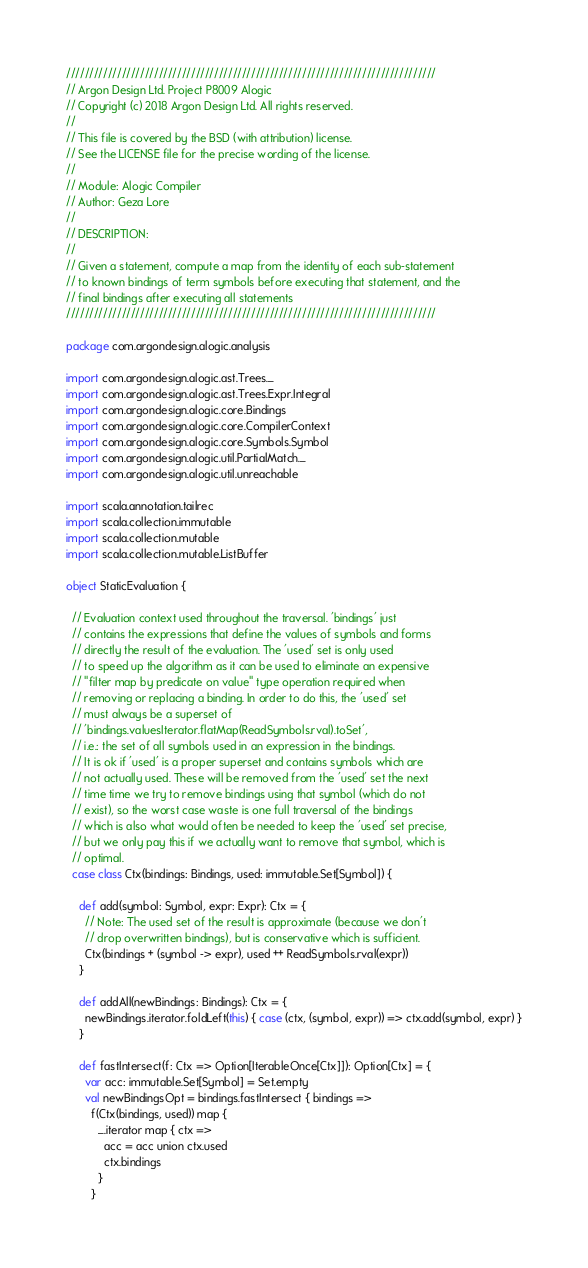<code> <loc_0><loc_0><loc_500><loc_500><_Scala_>////////////////////////////////////////////////////////////////////////////////
// Argon Design Ltd. Project P8009 Alogic
// Copyright (c) 2018 Argon Design Ltd. All rights reserved.
//
// This file is covered by the BSD (with attribution) license.
// See the LICENSE file for the precise wording of the license.
//
// Module: Alogic Compiler
// Author: Geza Lore
//
// DESCRIPTION:
//
// Given a statement, compute a map from the identity of each sub-statement
// to known bindings of term symbols before executing that statement, and the
// final bindings after executing all statements
////////////////////////////////////////////////////////////////////////////////

package com.argondesign.alogic.analysis

import com.argondesign.alogic.ast.Trees._
import com.argondesign.alogic.ast.Trees.Expr.Integral
import com.argondesign.alogic.core.Bindings
import com.argondesign.alogic.core.CompilerContext
import com.argondesign.alogic.core.Symbols.Symbol
import com.argondesign.alogic.util.PartialMatch._
import com.argondesign.alogic.util.unreachable

import scala.annotation.tailrec
import scala.collection.immutable
import scala.collection.mutable
import scala.collection.mutable.ListBuffer

object StaticEvaluation {

  // Evaluation context used throughout the traversal. 'bindings' just
  // contains the expressions that define the values of symbols and forms
  // directly the result of the evaluation. The 'used' set is only used
  // to speed up the algorithm as it can be used to eliminate an expensive
  // "filter map by predicate on value" type operation required when
  // removing or replacing a binding. In order to do this, the 'used' set
  // must always be a superset of
  // 'bindings.valuesIterator.flatMap(ReadSymbols.rval).toSet',
  // i.e.: the set of all symbols used in an expression in the bindings.
  // It is ok if 'used' is a proper superset and contains symbols which are
  // not actually used. These will be removed from the 'used' set the next
  // time time we try to remove bindings using that symbol (which do not
  // exist), so the worst case waste is one full traversal of the bindings
  // which is also what would often be needed to keep the 'used' set precise,
  // but we only pay this if we actually want to remove that symbol, which is
  // optimal.
  case class Ctx(bindings: Bindings, used: immutable.Set[Symbol]) {

    def add(symbol: Symbol, expr: Expr): Ctx = {
      // Note: The used set of the result is approximate (because we don't
      // drop overwritten bindings), but is conservative which is sufficient.
      Ctx(bindings + (symbol -> expr), used ++ ReadSymbols.rval(expr))
    }

    def addAll(newBindings: Bindings): Ctx = {
      newBindings.iterator.foldLeft(this) { case (ctx, (symbol, expr)) => ctx.add(symbol, expr) }
    }

    def fastIntersect(f: Ctx => Option[IterableOnce[Ctx]]): Option[Ctx] = {
      var acc: immutable.Set[Symbol] = Set.empty
      val newBindingsOpt = bindings.fastIntersect { bindings =>
        f(Ctx(bindings, used)) map {
          _.iterator map { ctx =>
            acc = acc union ctx.used
            ctx.bindings
          }
        }</code> 